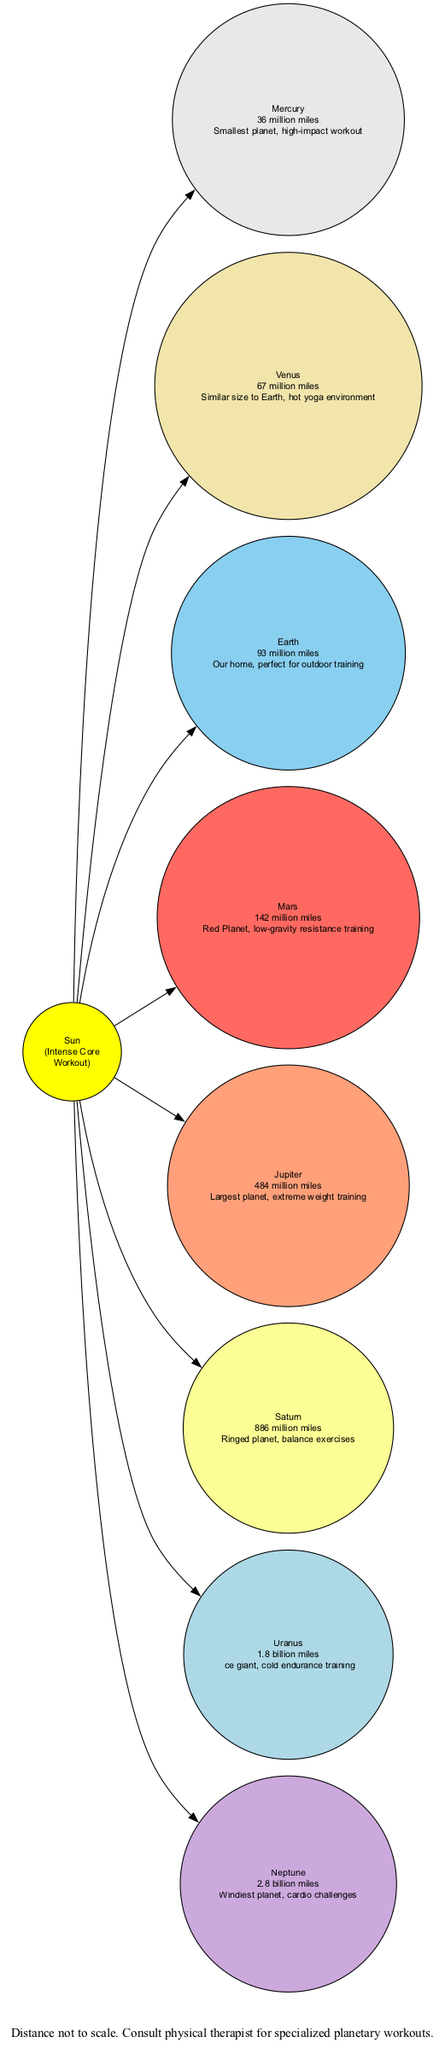What is the distance of Venus from the Sun? The diagram labels the distance of Venus from the Sun as "67 million miles". This information is found directly on the node for Venus.
Answer: 67 million miles Which planet is the farthest from the Sun? The diagram shows the distance of each planet from the Sun, and Neptune is the last in the list with a distance of "2.8 billion miles", making it the farthest planet from the Sun in this diagram.
Answer: Neptune How many planets are labeled in the diagram? The diagram includes eight planets, as evidenced by the individual nodes added for each planet (Mercury, Venus, Earth, Mars, Jupiter, Saturn, Uranus, and Neptune). Counting these gives the total number of labeled planets as eight.
Answer: 8 What type of workout is suggested for Jupiter? The node for Jupiter states "extreme weight training". This phrase is part of the note included with the Jupiter node, directly answering what type of workout is suggested for this planet.
Answer: Extreme weight training What is the note for Mars? The note accompanying Mars states "Red Planet, low-gravity resistance training". This phrase can be found distinctly under the Mars node in the diagram, providing specific information about Mars.
Answer: Red Planet, low-gravity resistance training Which planet has a note about balance exercises? According to the diagram, Saturn's note states "Ringed planet, balance exercises". This information can be identified clearly under the Saturn node, providing the specific workout type associated with Saturn.
Answer: Ringed planet, balance exercises How does Uranus differ from the other planets in terms of training? The note for Uranus mentions "Ice giant, cold endurance training", indicating that unlike other planets, it focuses on cold endurance, which is a unique aspect highlighted in its description compared to other workout types.
Answer: Cold endurance training What is the suggested workout type for Earth? The note for Earth indicates "Our home, perfect for outdoor training." This information can be found directly on the Earth node, clearly stating the workout type suggested.
Answer: Perfect for outdoor training 